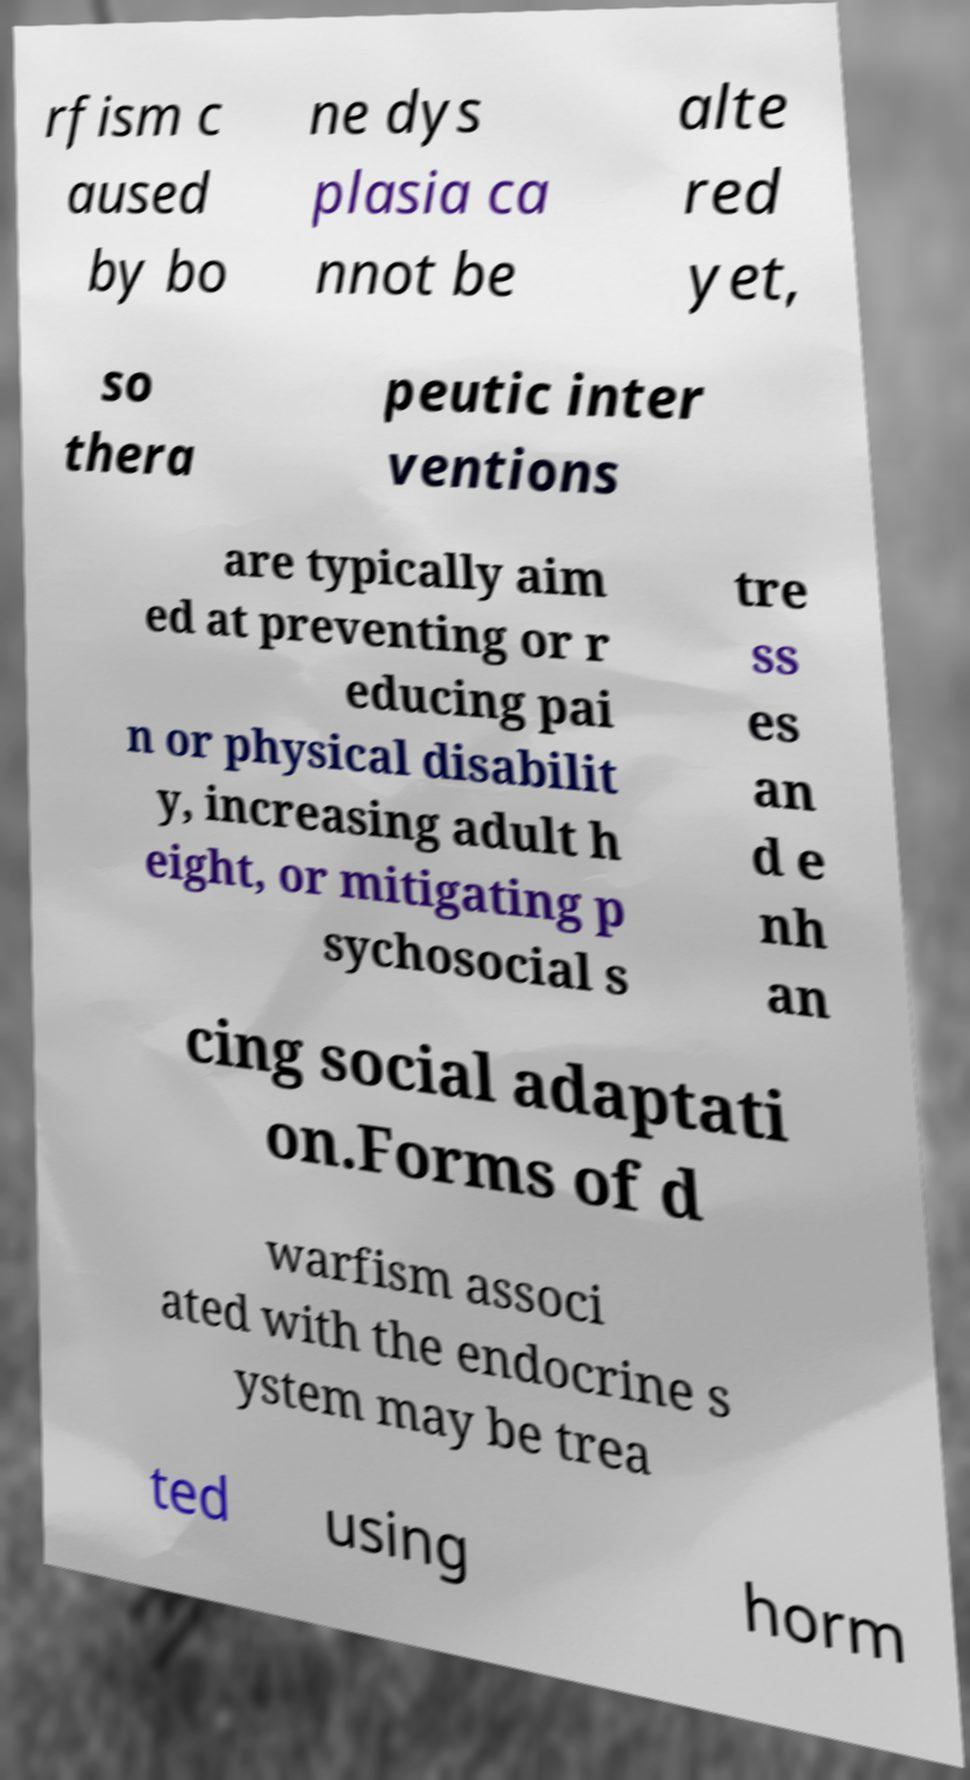What messages or text are displayed in this image? I need them in a readable, typed format. rfism c aused by bo ne dys plasia ca nnot be alte red yet, so thera peutic inter ventions are typically aim ed at preventing or r educing pai n or physical disabilit y, increasing adult h eight, or mitigating p sychosocial s tre ss es an d e nh an cing social adaptati on.Forms of d warfism associ ated with the endocrine s ystem may be trea ted using horm 